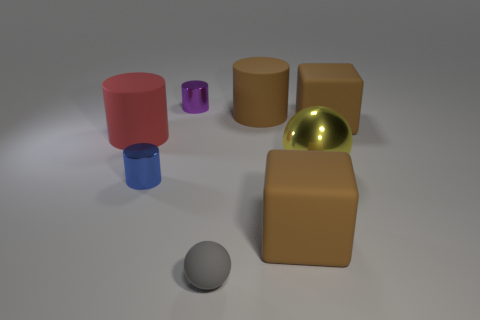If these objects were part of a game, how might the game be played? If these objects were part of a game, one could imagine a strategy game involving arranging the cylinders and spheres to achieve a certain balance or to create a specific pattern. The reflective ball could serve as a crucial piece that changes gameplay based on its position, perhaps acting as a 'sun' in a solar system-themed game, influencing the movements or roles of the other pieces. 